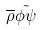Convert formula to latex. <formula><loc_0><loc_0><loc_500><loc_500>\overline { \rho } \tilde { \phi \psi }</formula> 